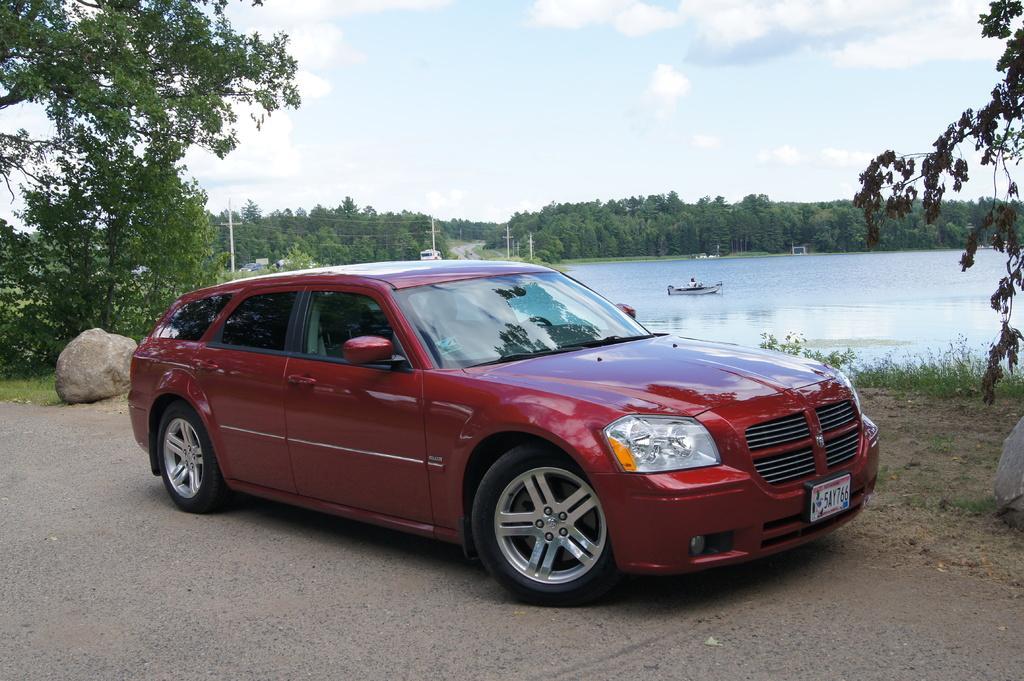How would you summarize this image in a sentence or two? In the center of the image a car is there. In the middle of the image we can see water, boat, trees, poles, rock are present. At the top of the image clouds are present in the sky. At the bottom of the image road is there. On the right side of the image some plants are there. 